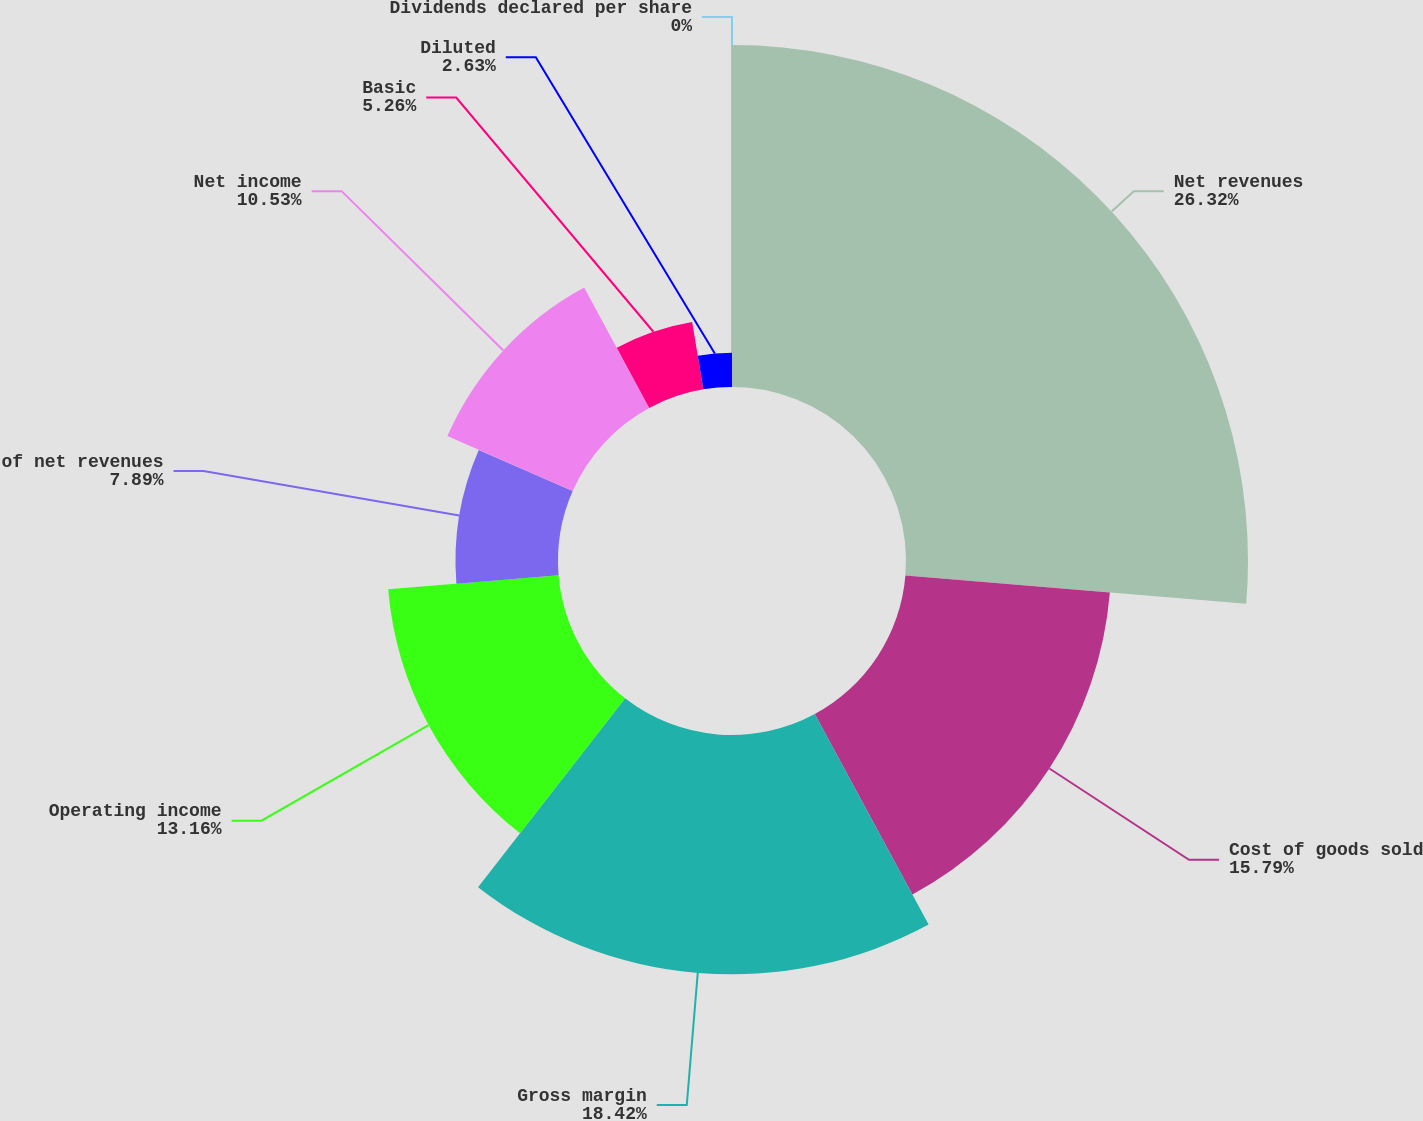Convert chart to OTSL. <chart><loc_0><loc_0><loc_500><loc_500><pie_chart><fcel>Net revenues<fcel>Cost of goods sold<fcel>Gross margin<fcel>Operating income<fcel>of net revenues<fcel>Net income<fcel>Basic<fcel>Diluted<fcel>Dividends declared per share<nl><fcel>26.32%<fcel>15.79%<fcel>18.42%<fcel>13.16%<fcel>7.89%<fcel>10.53%<fcel>5.26%<fcel>2.63%<fcel>0.0%<nl></chart> 